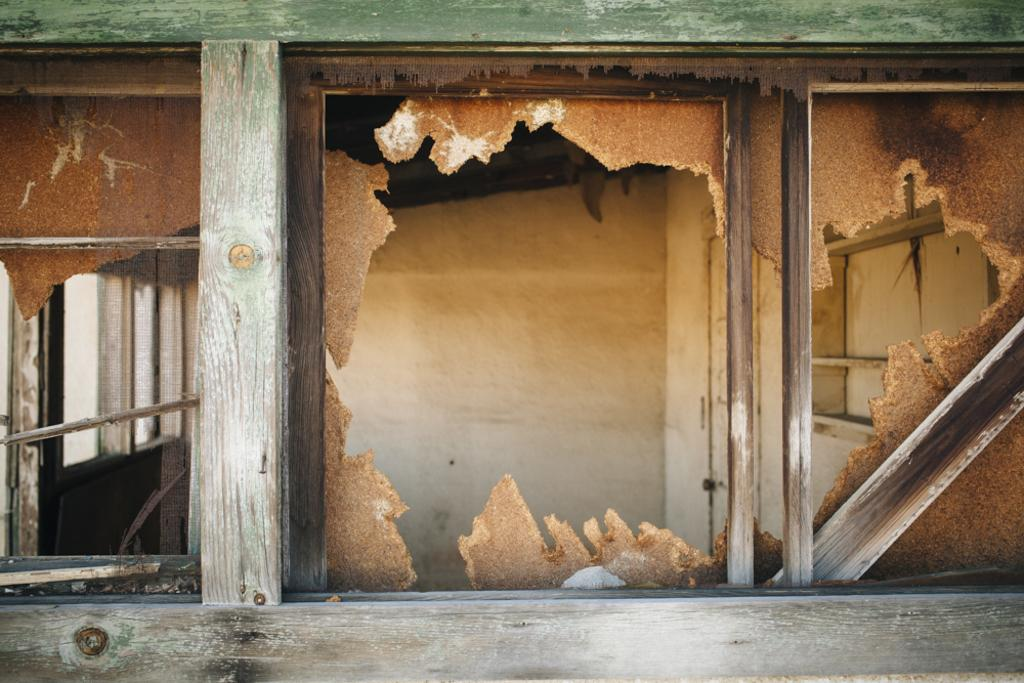How many windows are visible in the image? There are three windows in the image. What can be seen through the windows? Destroyed wooden objects are visible behind the windows. What is located in the background of the image? There is a wall visible in the background of the image. What type of experience does the queen have with the destroyed wooden objects in the image? There is no queen present in the image, and therefore no experience with the destroyed wooden objects can be observed. 